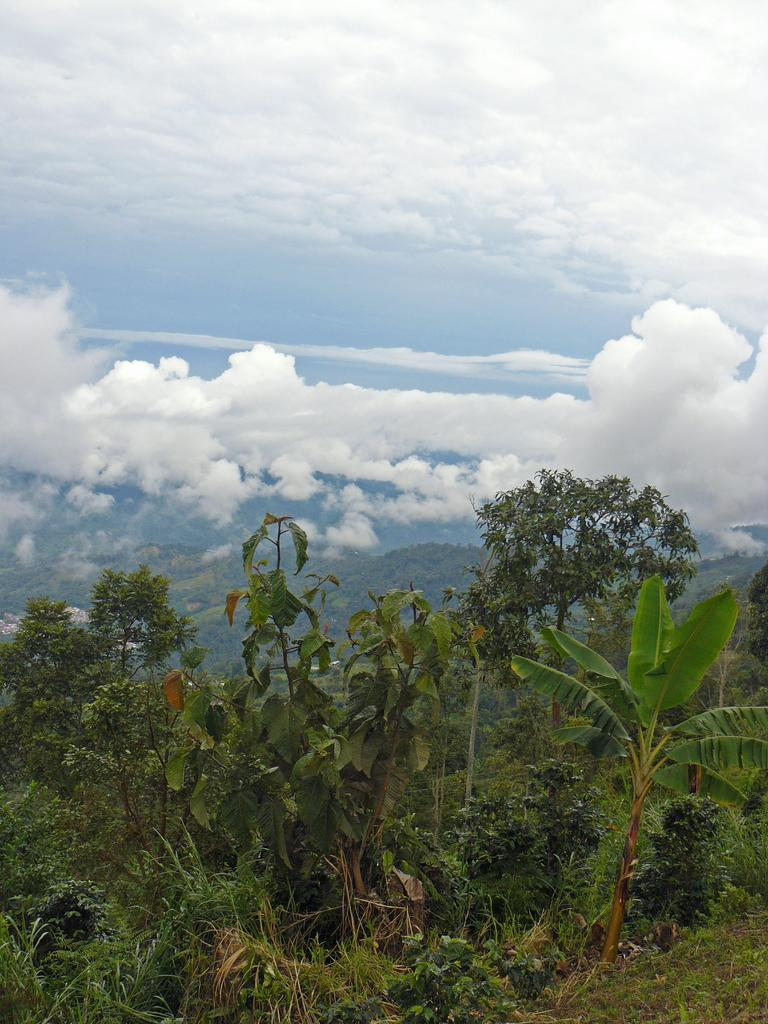What type of view is shown in the image? The image is an outside view. What can be seen at the bottom of the image? There are many plants and trees at the bottom of the image. What is visible at the top of the image? The sky is visible at the top of the image. What can be observed in the sky? Clouds are present in the sky. What color is the linen hanging on the clothesline in the image? There is no linen or clothesline present in the image. What time of day is it in the image? The provided facts do not give any information about the time of day, so it cannot be determined from the image. 